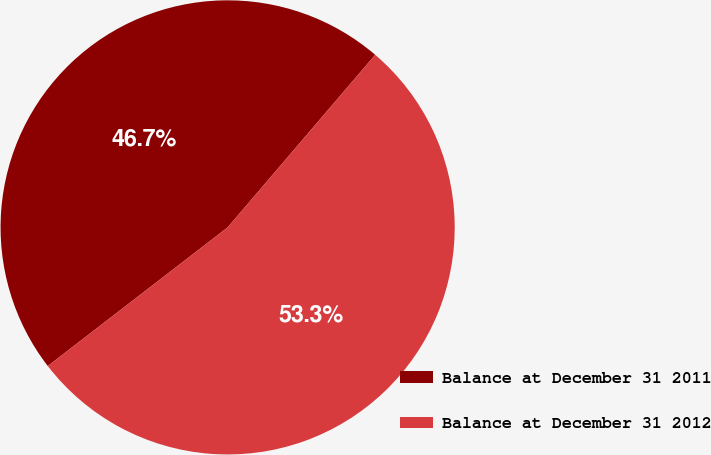<chart> <loc_0><loc_0><loc_500><loc_500><pie_chart><fcel>Balance at December 31 2011<fcel>Balance at December 31 2012<nl><fcel>46.71%<fcel>53.29%<nl></chart> 